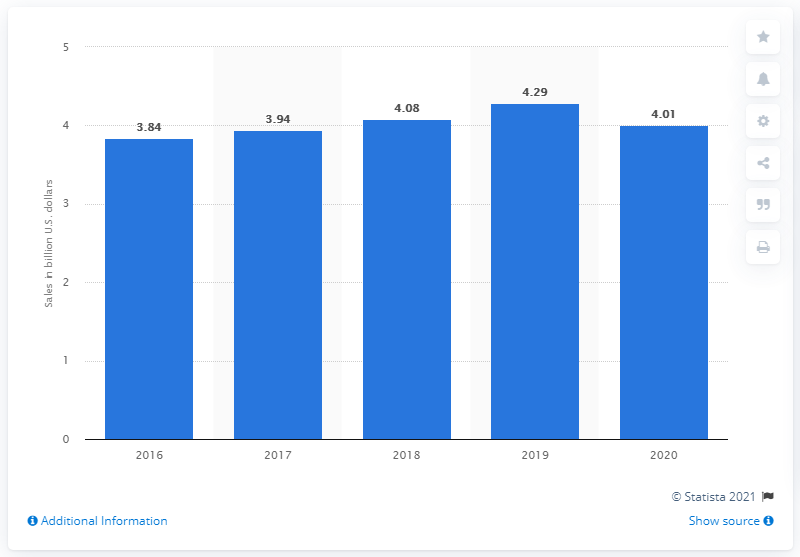Indicate a few pertinent items in this graphic. In 2019, Olive Garden's U.S. sales were $4.29 billion. In 2020, Olive Garden's U.S. sales were approximately $4.01 billion. 